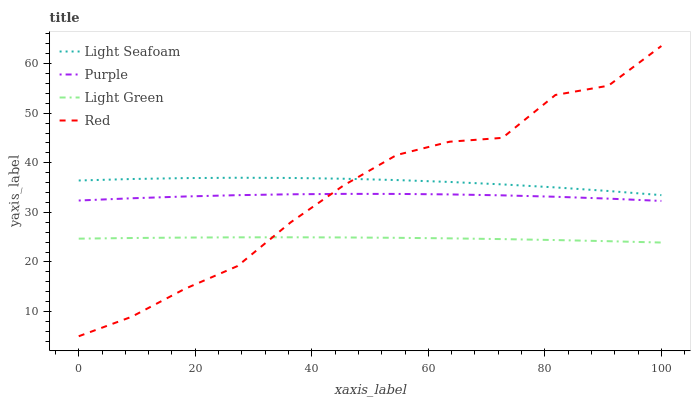Does Light Green have the minimum area under the curve?
Answer yes or no. Yes. Does Light Seafoam have the maximum area under the curve?
Answer yes or no. Yes. Does Red have the minimum area under the curve?
Answer yes or no. No. Does Red have the maximum area under the curve?
Answer yes or no. No. Is Light Green the smoothest?
Answer yes or no. Yes. Is Red the roughest?
Answer yes or no. Yes. Is Light Seafoam the smoothest?
Answer yes or no. No. Is Light Seafoam the roughest?
Answer yes or no. No. Does Red have the lowest value?
Answer yes or no. Yes. Does Light Seafoam have the lowest value?
Answer yes or no. No. Does Red have the highest value?
Answer yes or no. Yes. Does Light Seafoam have the highest value?
Answer yes or no. No. Is Light Green less than Light Seafoam?
Answer yes or no. Yes. Is Purple greater than Light Green?
Answer yes or no. Yes. Does Red intersect Light Seafoam?
Answer yes or no. Yes. Is Red less than Light Seafoam?
Answer yes or no. No. Is Red greater than Light Seafoam?
Answer yes or no. No. Does Light Green intersect Light Seafoam?
Answer yes or no. No. 